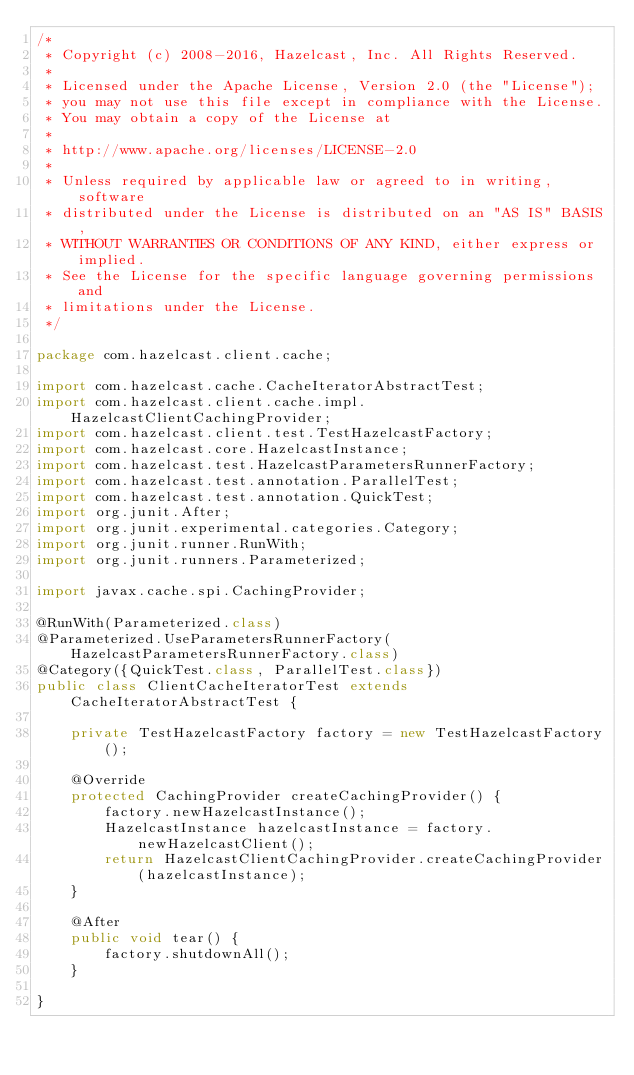Convert code to text. <code><loc_0><loc_0><loc_500><loc_500><_Java_>/*
 * Copyright (c) 2008-2016, Hazelcast, Inc. All Rights Reserved.
 *
 * Licensed under the Apache License, Version 2.0 (the "License");
 * you may not use this file except in compliance with the License.
 * You may obtain a copy of the License at
 *
 * http://www.apache.org/licenses/LICENSE-2.0
 *
 * Unless required by applicable law or agreed to in writing, software
 * distributed under the License is distributed on an "AS IS" BASIS,
 * WITHOUT WARRANTIES OR CONDITIONS OF ANY KIND, either express or implied.
 * See the License for the specific language governing permissions and
 * limitations under the License.
 */

package com.hazelcast.client.cache;

import com.hazelcast.cache.CacheIteratorAbstractTest;
import com.hazelcast.client.cache.impl.HazelcastClientCachingProvider;
import com.hazelcast.client.test.TestHazelcastFactory;
import com.hazelcast.core.HazelcastInstance;
import com.hazelcast.test.HazelcastParametersRunnerFactory;
import com.hazelcast.test.annotation.ParallelTest;
import com.hazelcast.test.annotation.QuickTest;
import org.junit.After;
import org.junit.experimental.categories.Category;
import org.junit.runner.RunWith;
import org.junit.runners.Parameterized;

import javax.cache.spi.CachingProvider;

@RunWith(Parameterized.class)
@Parameterized.UseParametersRunnerFactory(HazelcastParametersRunnerFactory.class)
@Category({QuickTest.class, ParallelTest.class})
public class ClientCacheIteratorTest extends CacheIteratorAbstractTest {

    private TestHazelcastFactory factory = new TestHazelcastFactory();

    @Override
    protected CachingProvider createCachingProvider() {
        factory.newHazelcastInstance();
        HazelcastInstance hazelcastInstance = factory.newHazelcastClient();
        return HazelcastClientCachingProvider.createCachingProvider(hazelcastInstance);
    }

    @After
    public void tear() {
        factory.shutdownAll();
    }

}

</code> 